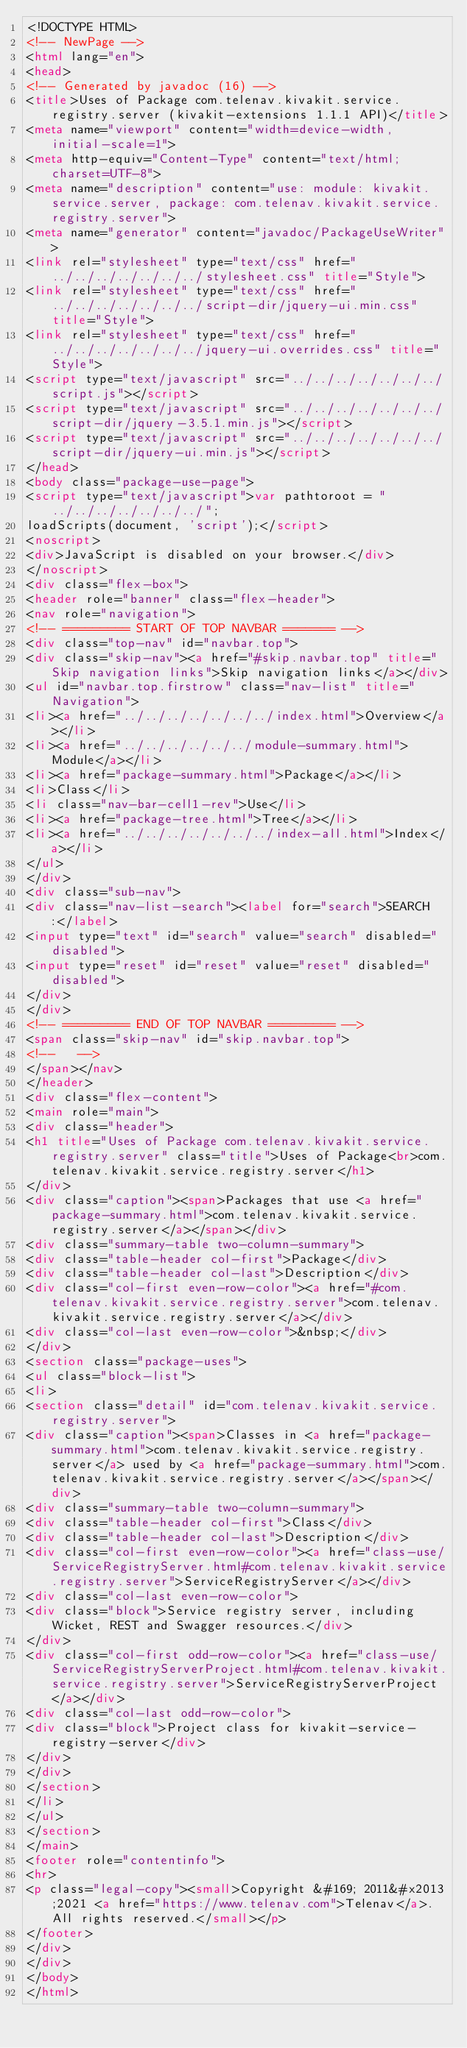Convert code to text. <code><loc_0><loc_0><loc_500><loc_500><_HTML_><!DOCTYPE HTML>
<!-- NewPage -->
<html lang="en">
<head>
<!-- Generated by javadoc (16) -->
<title>Uses of Package com.telenav.kivakit.service.registry.server (kivakit-extensions 1.1.1 API)</title>
<meta name="viewport" content="width=device-width, initial-scale=1">
<meta http-equiv="Content-Type" content="text/html; charset=UTF-8">
<meta name="description" content="use: module: kivakit.service.server, package: com.telenav.kivakit.service.registry.server">
<meta name="generator" content="javadoc/PackageUseWriter">
<link rel="stylesheet" type="text/css" href="../../../../../../../stylesheet.css" title="Style">
<link rel="stylesheet" type="text/css" href="../../../../../../../script-dir/jquery-ui.min.css" title="Style">
<link rel="stylesheet" type="text/css" href="../../../../../../../jquery-ui.overrides.css" title="Style">
<script type="text/javascript" src="../../../../../../../script.js"></script>
<script type="text/javascript" src="../../../../../../../script-dir/jquery-3.5.1.min.js"></script>
<script type="text/javascript" src="../../../../../../../script-dir/jquery-ui.min.js"></script>
</head>
<body class="package-use-page">
<script type="text/javascript">var pathtoroot = "../../../../../../../";
loadScripts(document, 'script');</script>
<noscript>
<div>JavaScript is disabled on your browser.</div>
</noscript>
<div class="flex-box">
<header role="banner" class="flex-header">
<nav role="navigation">
<!-- ========= START OF TOP NAVBAR ======= -->
<div class="top-nav" id="navbar.top">
<div class="skip-nav"><a href="#skip.navbar.top" title="Skip navigation links">Skip navigation links</a></div>
<ul id="navbar.top.firstrow" class="nav-list" title="Navigation">
<li><a href="../../../../../../../index.html">Overview</a></li>
<li><a href="../../../../../../module-summary.html">Module</a></li>
<li><a href="package-summary.html">Package</a></li>
<li>Class</li>
<li class="nav-bar-cell1-rev">Use</li>
<li><a href="package-tree.html">Tree</a></li>
<li><a href="../../../../../../../index-all.html">Index</a></li>
</ul>
</div>
<div class="sub-nav">
<div class="nav-list-search"><label for="search">SEARCH:</label>
<input type="text" id="search" value="search" disabled="disabled">
<input type="reset" id="reset" value="reset" disabled="disabled">
</div>
</div>
<!-- ========= END OF TOP NAVBAR ========= -->
<span class="skip-nav" id="skip.navbar.top">
<!--   -->
</span></nav>
</header>
<div class="flex-content">
<main role="main">
<div class="header">
<h1 title="Uses of Package com.telenav.kivakit.service.registry.server" class="title">Uses of Package<br>com.telenav.kivakit.service.registry.server</h1>
</div>
<div class="caption"><span>Packages that use <a href="package-summary.html">com.telenav.kivakit.service.registry.server</a></span></div>
<div class="summary-table two-column-summary">
<div class="table-header col-first">Package</div>
<div class="table-header col-last">Description</div>
<div class="col-first even-row-color"><a href="#com.telenav.kivakit.service.registry.server">com.telenav.kivakit.service.registry.server</a></div>
<div class="col-last even-row-color">&nbsp;</div>
</div>
<section class="package-uses">
<ul class="block-list">
<li>
<section class="detail" id="com.telenav.kivakit.service.registry.server">
<div class="caption"><span>Classes in <a href="package-summary.html">com.telenav.kivakit.service.registry.server</a> used by <a href="package-summary.html">com.telenav.kivakit.service.registry.server</a></span></div>
<div class="summary-table two-column-summary">
<div class="table-header col-first">Class</div>
<div class="table-header col-last">Description</div>
<div class="col-first even-row-color"><a href="class-use/ServiceRegistryServer.html#com.telenav.kivakit.service.registry.server">ServiceRegistryServer</a></div>
<div class="col-last even-row-color">
<div class="block">Service registry server, including Wicket, REST and Swagger resources.</div>
</div>
<div class="col-first odd-row-color"><a href="class-use/ServiceRegistryServerProject.html#com.telenav.kivakit.service.registry.server">ServiceRegistryServerProject</a></div>
<div class="col-last odd-row-color">
<div class="block">Project class for kivakit-service-registry-server</div>
</div>
</div>
</section>
</li>
</ul>
</section>
</main>
<footer role="contentinfo">
<hr>
<p class="legal-copy"><small>Copyright &#169; 2011&#x2013;2021 <a href="https://www.telenav.com">Telenav</a>. All rights reserved.</small></p>
</footer>
</div>
</div>
</body>
</html>
</code> 